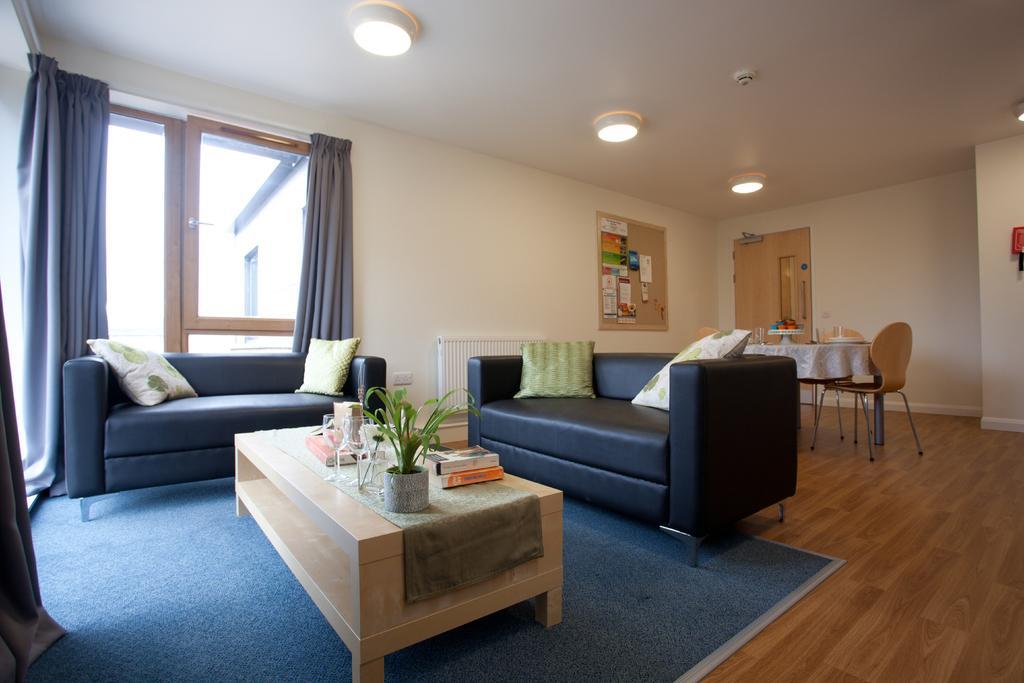Can you describe this image briefly? In the given image we can see a sofa and pillow on it. There is a table in front of sofa on which there are books, plant kept. There is a chair back of sofa and a window with gray color curtain. 